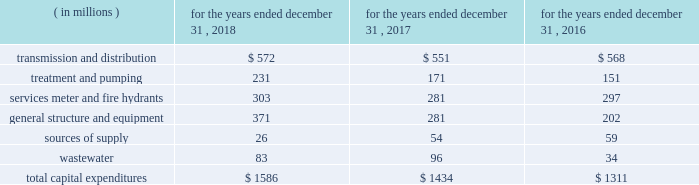The table provides a summary of our historical capital expenditures related to the upgrading of our infrastructure and systems: .
In 2018 , our capital expenditures increased $ 152 million , or 10.6% ( 10.6 % ) , primarily due to investment across the majority of our infrastructure categories .
In 2017 , our capital expenditures increased $ 123 million , or 9.4% ( 9.4 % ) , primarily due to investment in our general structure and equipment and wastewater categories .
We also grow our business primarily through acquisitions of water and wastewater systems , as well as other water-related services .
These acquisitions are complementary to our existing business and support continued geographical diversification and growth of our operations .
Generally , acquisitions are funded initially with short- term debt , and later refinanced with the proceeds from long-term debt .
The following is a summary of the acquisitions and dispositions affecting our cash flows from investing activities : 2022 the majority of cash paid for acquisitions pertained to the $ 365 million purchase of pivotal within our homeowner services group .
2022 paid $ 33 million for 15 water and wastewater systems , representing approximately 14000 customers .
2022 received $ 35 million for the sale of assets , including $ 27 million for the sale of the majority of the o&m contracts in our contract services group during the third quarter of 2018 .
2022 the majority of cash paid for acquisitions pertained to the $ 159 million purchase of the wastewater collection and treatment system assets of the municipal authority of the city of mckeesport , pennsylvania ( the 201cmckeesport system 201d ) , excluding a $ 5 million non-escrowed deposit made in 2016 .
2022 paid $ 18 million for 16 water and wastewater systems , excluding the mckeesport system and shorelands ( a stock-for-stock transaction ) , representing approximately 7000 customers .
2022 received $ 15 million for the sale of assets .
2022 paid $ 199 million for 15 water and wastewater systems , representing approximately 42000 customers .
2022 made a non-escrowed deposit of $ 5 million related to the mckeesport system acquisition .
2022 received $ 9 million for the sale of assets .
As previously noted , we expect to invest between $ 8.0 billion to $ 8.6 billion from 2019 to 2023 , with $ 7.3 billion of this range for infrastructure improvements in our regulated businesses .
In 2019 , we expect to .
Total transmission and distribution expenses in millions for the three year period equaled what? 
Computations: table_sum(transmission and distribution, none)
Answer: 1691.0. 